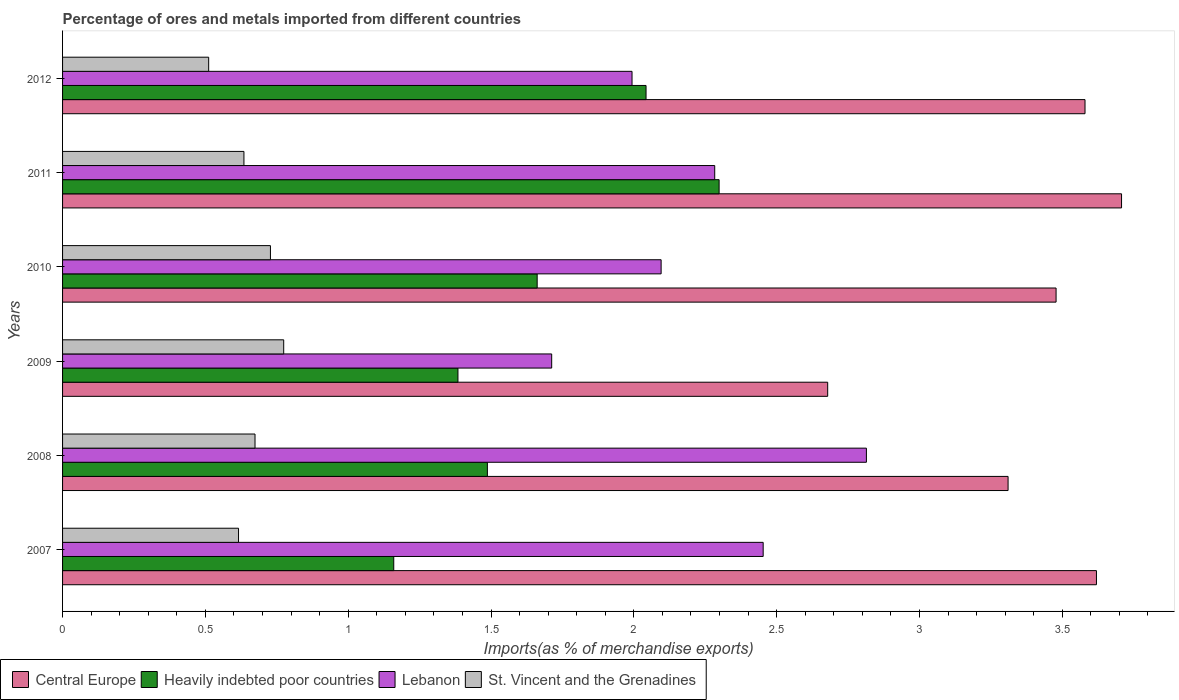How many different coloured bars are there?
Keep it short and to the point. 4. Are the number of bars on each tick of the Y-axis equal?
Give a very brief answer. Yes. What is the label of the 2nd group of bars from the top?
Your answer should be very brief. 2011. In how many cases, is the number of bars for a given year not equal to the number of legend labels?
Keep it short and to the point. 0. What is the percentage of imports to different countries in Lebanon in 2010?
Keep it short and to the point. 2.1. Across all years, what is the maximum percentage of imports to different countries in Heavily indebted poor countries?
Your response must be concise. 2.3. Across all years, what is the minimum percentage of imports to different countries in Heavily indebted poor countries?
Offer a terse response. 1.16. In which year was the percentage of imports to different countries in Central Europe minimum?
Your response must be concise. 2009. What is the total percentage of imports to different countries in Heavily indebted poor countries in the graph?
Your answer should be very brief. 10.03. What is the difference between the percentage of imports to different countries in St. Vincent and the Grenadines in 2009 and that in 2012?
Offer a very short reply. 0.26. What is the difference between the percentage of imports to different countries in Lebanon in 2010 and the percentage of imports to different countries in St. Vincent and the Grenadines in 2007?
Your response must be concise. 1.48. What is the average percentage of imports to different countries in St. Vincent and the Grenadines per year?
Give a very brief answer. 0.66. In the year 2009, what is the difference between the percentage of imports to different countries in St. Vincent and the Grenadines and percentage of imports to different countries in Heavily indebted poor countries?
Make the answer very short. -0.61. What is the ratio of the percentage of imports to different countries in Heavily indebted poor countries in 2011 to that in 2012?
Give a very brief answer. 1.13. Is the percentage of imports to different countries in Heavily indebted poor countries in 2011 less than that in 2012?
Provide a succinct answer. No. Is the difference between the percentage of imports to different countries in St. Vincent and the Grenadines in 2007 and 2010 greater than the difference between the percentage of imports to different countries in Heavily indebted poor countries in 2007 and 2010?
Offer a very short reply. Yes. What is the difference between the highest and the second highest percentage of imports to different countries in Central Europe?
Provide a succinct answer. 0.09. What is the difference between the highest and the lowest percentage of imports to different countries in Central Europe?
Your answer should be very brief. 1.03. What does the 4th bar from the top in 2011 represents?
Give a very brief answer. Central Europe. What does the 4th bar from the bottom in 2009 represents?
Make the answer very short. St. Vincent and the Grenadines. Is it the case that in every year, the sum of the percentage of imports to different countries in St. Vincent and the Grenadines and percentage of imports to different countries in Heavily indebted poor countries is greater than the percentage of imports to different countries in Lebanon?
Ensure brevity in your answer.  No. Are all the bars in the graph horizontal?
Offer a terse response. Yes. What is the difference between two consecutive major ticks on the X-axis?
Offer a terse response. 0.5. Does the graph contain any zero values?
Offer a terse response. No. How are the legend labels stacked?
Your answer should be compact. Horizontal. What is the title of the graph?
Provide a succinct answer. Percentage of ores and metals imported from different countries. Does "Thailand" appear as one of the legend labels in the graph?
Ensure brevity in your answer.  No. What is the label or title of the X-axis?
Ensure brevity in your answer.  Imports(as % of merchandise exports). What is the Imports(as % of merchandise exports) in Central Europe in 2007?
Offer a very short reply. 3.62. What is the Imports(as % of merchandise exports) of Heavily indebted poor countries in 2007?
Your answer should be compact. 1.16. What is the Imports(as % of merchandise exports) of Lebanon in 2007?
Your answer should be compact. 2.45. What is the Imports(as % of merchandise exports) in St. Vincent and the Grenadines in 2007?
Keep it short and to the point. 0.62. What is the Imports(as % of merchandise exports) in Central Europe in 2008?
Your answer should be compact. 3.31. What is the Imports(as % of merchandise exports) of Heavily indebted poor countries in 2008?
Provide a short and direct response. 1.49. What is the Imports(as % of merchandise exports) in Lebanon in 2008?
Ensure brevity in your answer.  2.81. What is the Imports(as % of merchandise exports) in St. Vincent and the Grenadines in 2008?
Ensure brevity in your answer.  0.67. What is the Imports(as % of merchandise exports) in Central Europe in 2009?
Your response must be concise. 2.68. What is the Imports(as % of merchandise exports) in Heavily indebted poor countries in 2009?
Ensure brevity in your answer.  1.38. What is the Imports(as % of merchandise exports) in Lebanon in 2009?
Provide a succinct answer. 1.71. What is the Imports(as % of merchandise exports) of St. Vincent and the Grenadines in 2009?
Your answer should be very brief. 0.77. What is the Imports(as % of merchandise exports) of Central Europe in 2010?
Provide a short and direct response. 3.48. What is the Imports(as % of merchandise exports) in Heavily indebted poor countries in 2010?
Your answer should be compact. 1.66. What is the Imports(as % of merchandise exports) of Lebanon in 2010?
Offer a very short reply. 2.1. What is the Imports(as % of merchandise exports) in St. Vincent and the Grenadines in 2010?
Your answer should be compact. 0.73. What is the Imports(as % of merchandise exports) of Central Europe in 2011?
Ensure brevity in your answer.  3.71. What is the Imports(as % of merchandise exports) in Heavily indebted poor countries in 2011?
Make the answer very short. 2.3. What is the Imports(as % of merchandise exports) in Lebanon in 2011?
Your response must be concise. 2.28. What is the Imports(as % of merchandise exports) in St. Vincent and the Grenadines in 2011?
Give a very brief answer. 0.64. What is the Imports(as % of merchandise exports) of Central Europe in 2012?
Keep it short and to the point. 3.58. What is the Imports(as % of merchandise exports) of Heavily indebted poor countries in 2012?
Offer a very short reply. 2.04. What is the Imports(as % of merchandise exports) in Lebanon in 2012?
Provide a short and direct response. 1.99. What is the Imports(as % of merchandise exports) of St. Vincent and the Grenadines in 2012?
Give a very brief answer. 0.51. Across all years, what is the maximum Imports(as % of merchandise exports) of Central Europe?
Keep it short and to the point. 3.71. Across all years, what is the maximum Imports(as % of merchandise exports) of Heavily indebted poor countries?
Provide a short and direct response. 2.3. Across all years, what is the maximum Imports(as % of merchandise exports) in Lebanon?
Offer a terse response. 2.81. Across all years, what is the maximum Imports(as % of merchandise exports) in St. Vincent and the Grenadines?
Keep it short and to the point. 0.77. Across all years, what is the minimum Imports(as % of merchandise exports) in Central Europe?
Give a very brief answer. 2.68. Across all years, what is the minimum Imports(as % of merchandise exports) of Heavily indebted poor countries?
Keep it short and to the point. 1.16. Across all years, what is the minimum Imports(as % of merchandise exports) of Lebanon?
Provide a succinct answer. 1.71. Across all years, what is the minimum Imports(as % of merchandise exports) of St. Vincent and the Grenadines?
Your answer should be very brief. 0.51. What is the total Imports(as % of merchandise exports) of Central Europe in the graph?
Your response must be concise. 20.37. What is the total Imports(as % of merchandise exports) in Heavily indebted poor countries in the graph?
Provide a short and direct response. 10.03. What is the total Imports(as % of merchandise exports) in Lebanon in the graph?
Provide a succinct answer. 13.35. What is the total Imports(as % of merchandise exports) of St. Vincent and the Grenadines in the graph?
Your answer should be compact. 3.94. What is the difference between the Imports(as % of merchandise exports) of Central Europe in 2007 and that in 2008?
Your answer should be compact. 0.31. What is the difference between the Imports(as % of merchandise exports) in Heavily indebted poor countries in 2007 and that in 2008?
Ensure brevity in your answer.  -0.33. What is the difference between the Imports(as % of merchandise exports) of Lebanon in 2007 and that in 2008?
Offer a terse response. -0.36. What is the difference between the Imports(as % of merchandise exports) of St. Vincent and the Grenadines in 2007 and that in 2008?
Ensure brevity in your answer.  -0.06. What is the difference between the Imports(as % of merchandise exports) of Central Europe in 2007 and that in 2009?
Make the answer very short. 0.94. What is the difference between the Imports(as % of merchandise exports) in Heavily indebted poor countries in 2007 and that in 2009?
Provide a succinct answer. -0.22. What is the difference between the Imports(as % of merchandise exports) in Lebanon in 2007 and that in 2009?
Provide a succinct answer. 0.74. What is the difference between the Imports(as % of merchandise exports) in St. Vincent and the Grenadines in 2007 and that in 2009?
Provide a short and direct response. -0.16. What is the difference between the Imports(as % of merchandise exports) of Central Europe in 2007 and that in 2010?
Give a very brief answer. 0.14. What is the difference between the Imports(as % of merchandise exports) in Heavily indebted poor countries in 2007 and that in 2010?
Provide a short and direct response. -0.5. What is the difference between the Imports(as % of merchandise exports) in Lebanon in 2007 and that in 2010?
Ensure brevity in your answer.  0.36. What is the difference between the Imports(as % of merchandise exports) of St. Vincent and the Grenadines in 2007 and that in 2010?
Provide a succinct answer. -0.11. What is the difference between the Imports(as % of merchandise exports) of Central Europe in 2007 and that in 2011?
Give a very brief answer. -0.09. What is the difference between the Imports(as % of merchandise exports) of Heavily indebted poor countries in 2007 and that in 2011?
Your answer should be very brief. -1.14. What is the difference between the Imports(as % of merchandise exports) in Lebanon in 2007 and that in 2011?
Offer a terse response. 0.17. What is the difference between the Imports(as % of merchandise exports) in St. Vincent and the Grenadines in 2007 and that in 2011?
Provide a short and direct response. -0.02. What is the difference between the Imports(as % of merchandise exports) of Heavily indebted poor countries in 2007 and that in 2012?
Provide a short and direct response. -0.88. What is the difference between the Imports(as % of merchandise exports) of Lebanon in 2007 and that in 2012?
Your response must be concise. 0.46. What is the difference between the Imports(as % of merchandise exports) in St. Vincent and the Grenadines in 2007 and that in 2012?
Give a very brief answer. 0.1. What is the difference between the Imports(as % of merchandise exports) of Central Europe in 2008 and that in 2009?
Your answer should be very brief. 0.63. What is the difference between the Imports(as % of merchandise exports) in Heavily indebted poor countries in 2008 and that in 2009?
Give a very brief answer. 0.1. What is the difference between the Imports(as % of merchandise exports) in Lebanon in 2008 and that in 2009?
Your answer should be compact. 1.1. What is the difference between the Imports(as % of merchandise exports) of St. Vincent and the Grenadines in 2008 and that in 2009?
Keep it short and to the point. -0.1. What is the difference between the Imports(as % of merchandise exports) in Central Europe in 2008 and that in 2010?
Offer a terse response. -0.17. What is the difference between the Imports(as % of merchandise exports) in Heavily indebted poor countries in 2008 and that in 2010?
Offer a terse response. -0.17. What is the difference between the Imports(as % of merchandise exports) of Lebanon in 2008 and that in 2010?
Give a very brief answer. 0.72. What is the difference between the Imports(as % of merchandise exports) in St. Vincent and the Grenadines in 2008 and that in 2010?
Your answer should be very brief. -0.05. What is the difference between the Imports(as % of merchandise exports) in Central Europe in 2008 and that in 2011?
Your answer should be compact. -0.4. What is the difference between the Imports(as % of merchandise exports) in Heavily indebted poor countries in 2008 and that in 2011?
Offer a terse response. -0.81. What is the difference between the Imports(as % of merchandise exports) of Lebanon in 2008 and that in 2011?
Offer a terse response. 0.53. What is the difference between the Imports(as % of merchandise exports) in St. Vincent and the Grenadines in 2008 and that in 2011?
Provide a short and direct response. 0.04. What is the difference between the Imports(as % of merchandise exports) of Central Europe in 2008 and that in 2012?
Give a very brief answer. -0.27. What is the difference between the Imports(as % of merchandise exports) in Heavily indebted poor countries in 2008 and that in 2012?
Give a very brief answer. -0.56. What is the difference between the Imports(as % of merchandise exports) in Lebanon in 2008 and that in 2012?
Provide a short and direct response. 0.82. What is the difference between the Imports(as % of merchandise exports) of St. Vincent and the Grenadines in 2008 and that in 2012?
Your answer should be compact. 0.16. What is the difference between the Imports(as % of merchandise exports) of Central Europe in 2009 and that in 2010?
Provide a succinct answer. -0.8. What is the difference between the Imports(as % of merchandise exports) in Heavily indebted poor countries in 2009 and that in 2010?
Your response must be concise. -0.28. What is the difference between the Imports(as % of merchandise exports) in Lebanon in 2009 and that in 2010?
Give a very brief answer. -0.38. What is the difference between the Imports(as % of merchandise exports) of St. Vincent and the Grenadines in 2009 and that in 2010?
Your answer should be very brief. 0.05. What is the difference between the Imports(as % of merchandise exports) of Central Europe in 2009 and that in 2011?
Keep it short and to the point. -1.03. What is the difference between the Imports(as % of merchandise exports) of Heavily indebted poor countries in 2009 and that in 2011?
Your answer should be very brief. -0.91. What is the difference between the Imports(as % of merchandise exports) in Lebanon in 2009 and that in 2011?
Offer a very short reply. -0.57. What is the difference between the Imports(as % of merchandise exports) of St. Vincent and the Grenadines in 2009 and that in 2011?
Make the answer very short. 0.14. What is the difference between the Imports(as % of merchandise exports) of Central Europe in 2009 and that in 2012?
Offer a terse response. -0.9. What is the difference between the Imports(as % of merchandise exports) in Heavily indebted poor countries in 2009 and that in 2012?
Make the answer very short. -0.66. What is the difference between the Imports(as % of merchandise exports) of Lebanon in 2009 and that in 2012?
Your response must be concise. -0.28. What is the difference between the Imports(as % of merchandise exports) of St. Vincent and the Grenadines in 2009 and that in 2012?
Keep it short and to the point. 0.26. What is the difference between the Imports(as % of merchandise exports) in Central Europe in 2010 and that in 2011?
Provide a short and direct response. -0.23. What is the difference between the Imports(as % of merchandise exports) of Heavily indebted poor countries in 2010 and that in 2011?
Your response must be concise. -0.64. What is the difference between the Imports(as % of merchandise exports) in Lebanon in 2010 and that in 2011?
Your answer should be very brief. -0.19. What is the difference between the Imports(as % of merchandise exports) in St. Vincent and the Grenadines in 2010 and that in 2011?
Your answer should be compact. 0.09. What is the difference between the Imports(as % of merchandise exports) of Central Europe in 2010 and that in 2012?
Provide a short and direct response. -0.1. What is the difference between the Imports(as % of merchandise exports) of Heavily indebted poor countries in 2010 and that in 2012?
Keep it short and to the point. -0.38. What is the difference between the Imports(as % of merchandise exports) of Lebanon in 2010 and that in 2012?
Offer a terse response. 0.1. What is the difference between the Imports(as % of merchandise exports) in St. Vincent and the Grenadines in 2010 and that in 2012?
Make the answer very short. 0.22. What is the difference between the Imports(as % of merchandise exports) of Central Europe in 2011 and that in 2012?
Offer a very short reply. 0.13. What is the difference between the Imports(as % of merchandise exports) in Heavily indebted poor countries in 2011 and that in 2012?
Provide a short and direct response. 0.26. What is the difference between the Imports(as % of merchandise exports) of Lebanon in 2011 and that in 2012?
Your response must be concise. 0.29. What is the difference between the Imports(as % of merchandise exports) of St. Vincent and the Grenadines in 2011 and that in 2012?
Your answer should be very brief. 0.12. What is the difference between the Imports(as % of merchandise exports) of Central Europe in 2007 and the Imports(as % of merchandise exports) of Heavily indebted poor countries in 2008?
Your response must be concise. 2.13. What is the difference between the Imports(as % of merchandise exports) in Central Europe in 2007 and the Imports(as % of merchandise exports) in Lebanon in 2008?
Offer a very short reply. 0.81. What is the difference between the Imports(as % of merchandise exports) of Central Europe in 2007 and the Imports(as % of merchandise exports) of St. Vincent and the Grenadines in 2008?
Your answer should be very brief. 2.95. What is the difference between the Imports(as % of merchandise exports) in Heavily indebted poor countries in 2007 and the Imports(as % of merchandise exports) in Lebanon in 2008?
Keep it short and to the point. -1.65. What is the difference between the Imports(as % of merchandise exports) in Heavily indebted poor countries in 2007 and the Imports(as % of merchandise exports) in St. Vincent and the Grenadines in 2008?
Your response must be concise. 0.49. What is the difference between the Imports(as % of merchandise exports) of Lebanon in 2007 and the Imports(as % of merchandise exports) of St. Vincent and the Grenadines in 2008?
Make the answer very short. 1.78. What is the difference between the Imports(as % of merchandise exports) of Central Europe in 2007 and the Imports(as % of merchandise exports) of Heavily indebted poor countries in 2009?
Your answer should be very brief. 2.24. What is the difference between the Imports(as % of merchandise exports) in Central Europe in 2007 and the Imports(as % of merchandise exports) in Lebanon in 2009?
Give a very brief answer. 1.91. What is the difference between the Imports(as % of merchandise exports) in Central Europe in 2007 and the Imports(as % of merchandise exports) in St. Vincent and the Grenadines in 2009?
Keep it short and to the point. 2.85. What is the difference between the Imports(as % of merchandise exports) in Heavily indebted poor countries in 2007 and the Imports(as % of merchandise exports) in Lebanon in 2009?
Offer a very short reply. -0.55. What is the difference between the Imports(as % of merchandise exports) of Heavily indebted poor countries in 2007 and the Imports(as % of merchandise exports) of St. Vincent and the Grenadines in 2009?
Your response must be concise. 0.39. What is the difference between the Imports(as % of merchandise exports) in Lebanon in 2007 and the Imports(as % of merchandise exports) in St. Vincent and the Grenadines in 2009?
Give a very brief answer. 1.68. What is the difference between the Imports(as % of merchandise exports) in Central Europe in 2007 and the Imports(as % of merchandise exports) in Heavily indebted poor countries in 2010?
Offer a very short reply. 1.96. What is the difference between the Imports(as % of merchandise exports) of Central Europe in 2007 and the Imports(as % of merchandise exports) of Lebanon in 2010?
Your answer should be very brief. 1.52. What is the difference between the Imports(as % of merchandise exports) in Central Europe in 2007 and the Imports(as % of merchandise exports) in St. Vincent and the Grenadines in 2010?
Your response must be concise. 2.89. What is the difference between the Imports(as % of merchandise exports) of Heavily indebted poor countries in 2007 and the Imports(as % of merchandise exports) of Lebanon in 2010?
Give a very brief answer. -0.94. What is the difference between the Imports(as % of merchandise exports) of Heavily indebted poor countries in 2007 and the Imports(as % of merchandise exports) of St. Vincent and the Grenadines in 2010?
Your response must be concise. 0.43. What is the difference between the Imports(as % of merchandise exports) in Lebanon in 2007 and the Imports(as % of merchandise exports) in St. Vincent and the Grenadines in 2010?
Ensure brevity in your answer.  1.73. What is the difference between the Imports(as % of merchandise exports) in Central Europe in 2007 and the Imports(as % of merchandise exports) in Heavily indebted poor countries in 2011?
Provide a short and direct response. 1.32. What is the difference between the Imports(as % of merchandise exports) of Central Europe in 2007 and the Imports(as % of merchandise exports) of Lebanon in 2011?
Keep it short and to the point. 1.34. What is the difference between the Imports(as % of merchandise exports) in Central Europe in 2007 and the Imports(as % of merchandise exports) in St. Vincent and the Grenadines in 2011?
Give a very brief answer. 2.98. What is the difference between the Imports(as % of merchandise exports) of Heavily indebted poor countries in 2007 and the Imports(as % of merchandise exports) of Lebanon in 2011?
Offer a very short reply. -1.12. What is the difference between the Imports(as % of merchandise exports) of Heavily indebted poor countries in 2007 and the Imports(as % of merchandise exports) of St. Vincent and the Grenadines in 2011?
Your answer should be compact. 0.52. What is the difference between the Imports(as % of merchandise exports) in Lebanon in 2007 and the Imports(as % of merchandise exports) in St. Vincent and the Grenadines in 2011?
Your response must be concise. 1.82. What is the difference between the Imports(as % of merchandise exports) in Central Europe in 2007 and the Imports(as % of merchandise exports) in Heavily indebted poor countries in 2012?
Make the answer very short. 1.58. What is the difference between the Imports(as % of merchandise exports) in Central Europe in 2007 and the Imports(as % of merchandise exports) in Lebanon in 2012?
Provide a succinct answer. 1.63. What is the difference between the Imports(as % of merchandise exports) of Central Europe in 2007 and the Imports(as % of merchandise exports) of St. Vincent and the Grenadines in 2012?
Make the answer very short. 3.11. What is the difference between the Imports(as % of merchandise exports) of Heavily indebted poor countries in 2007 and the Imports(as % of merchandise exports) of Lebanon in 2012?
Provide a succinct answer. -0.83. What is the difference between the Imports(as % of merchandise exports) of Heavily indebted poor countries in 2007 and the Imports(as % of merchandise exports) of St. Vincent and the Grenadines in 2012?
Offer a terse response. 0.65. What is the difference between the Imports(as % of merchandise exports) of Lebanon in 2007 and the Imports(as % of merchandise exports) of St. Vincent and the Grenadines in 2012?
Ensure brevity in your answer.  1.94. What is the difference between the Imports(as % of merchandise exports) in Central Europe in 2008 and the Imports(as % of merchandise exports) in Heavily indebted poor countries in 2009?
Keep it short and to the point. 1.93. What is the difference between the Imports(as % of merchandise exports) in Central Europe in 2008 and the Imports(as % of merchandise exports) in Lebanon in 2009?
Offer a terse response. 1.6. What is the difference between the Imports(as % of merchandise exports) of Central Europe in 2008 and the Imports(as % of merchandise exports) of St. Vincent and the Grenadines in 2009?
Offer a very short reply. 2.54. What is the difference between the Imports(as % of merchandise exports) of Heavily indebted poor countries in 2008 and the Imports(as % of merchandise exports) of Lebanon in 2009?
Offer a very short reply. -0.23. What is the difference between the Imports(as % of merchandise exports) of Heavily indebted poor countries in 2008 and the Imports(as % of merchandise exports) of St. Vincent and the Grenadines in 2009?
Offer a very short reply. 0.71. What is the difference between the Imports(as % of merchandise exports) of Lebanon in 2008 and the Imports(as % of merchandise exports) of St. Vincent and the Grenadines in 2009?
Your answer should be very brief. 2.04. What is the difference between the Imports(as % of merchandise exports) in Central Europe in 2008 and the Imports(as % of merchandise exports) in Heavily indebted poor countries in 2010?
Your answer should be compact. 1.65. What is the difference between the Imports(as % of merchandise exports) in Central Europe in 2008 and the Imports(as % of merchandise exports) in Lebanon in 2010?
Offer a very short reply. 1.21. What is the difference between the Imports(as % of merchandise exports) in Central Europe in 2008 and the Imports(as % of merchandise exports) in St. Vincent and the Grenadines in 2010?
Your response must be concise. 2.58. What is the difference between the Imports(as % of merchandise exports) of Heavily indebted poor countries in 2008 and the Imports(as % of merchandise exports) of Lebanon in 2010?
Provide a succinct answer. -0.61. What is the difference between the Imports(as % of merchandise exports) in Heavily indebted poor countries in 2008 and the Imports(as % of merchandise exports) in St. Vincent and the Grenadines in 2010?
Your answer should be compact. 0.76. What is the difference between the Imports(as % of merchandise exports) of Lebanon in 2008 and the Imports(as % of merchandise exports) of St. Vincent and the Grenadines in 2010?
Offer a terse response. 2.09. What is the difference between the Imports(as % of merchandise exports) in Central Europe in 2008 and the Imports(as % of merchandise exports) in Heavily indebted poor countries in 2011?
Provide a short and direct response. 1.01. What is the difference between the Imports(as % of merchandise exports) of Central Europe in 2008 and the Imports(as % of merchandise exports) of Lebanon in 2011?
Provide a short and direct response. 1.03. What is the difference between the Imports(as % of merchandise exports) in Central Europe in 2008 and the Imports(as % of merchandise exports) in St. Vincent and the Grenadines in 2011?
Ensure brevity in your answer.  2.68. What is the difference between the Imports(as % of merchandise exports) of Heavily indebted poor countries in 2008 and the Imports(as % of merchandise exports) of Lebanon in 2011?
Provide a short and direct response. -0.8. What is the difference between the Imports(as % of merchandise exports) of Heavily indebted poor countries in 2008 and the Imports(as % of merchandise exports) of St. Vincent and the Grenadines in 2011?
Provide a succinct answer. 0.85. What is the difference between the Imports(as % of merchandise exports) in Lebanon in 2008 and the Imports(as % of merchandise exports) in St. Vincent and the Grenadines in 2011?
Your answer should be compact. 2.18. What is the difference between the Imports(as % of merchandise exports) of Central Europe in 2008 and the Imports(as % of merchandise exports) of Heavily indebted poor countries in 2012?
Offer a terse response. 1.27. What is the difference between the Imports(as % of merchandise exports) of Central Europe in 2008 and the Imports(as % of merchandise exports) of Lebanon in 2012?
Make the answer very short. 1.32. What is the difference between the Imports(as % of merchandise exports) in Central Europe in 2008 and the Imports(as % of merchandise exports) in St. Vincent and the Grenadines in 2012?
Your response must be concise. 2.8. What is the difference between the Imports(as % of merchandise exports) in Heavily indebted poor countries in 2008 and the Imports(as % of merchandise exports) in Lebanon in 2012?
Give a very brief answer. -0.51. What is the difference between the Imports(as % of merchandise exports) of Heavily indebted poor countries in 2008 and the Imports(as % of merchandise exports) of St. Vincent and the Grenadines in 2012?
Offer a terse response. 0.98. What is the difference between the Imports(as % of merchandise exports) of Lebanon in 2008 and the Imports(as % of merchandise exports) of St. Vincent and the Grenadines in 2012?
Keep it short and to the point. 2.3. What is the difference between the Imports(as % of merchandise exports) of Central Europe in 2009 and the Imports(as % of merchandise exports) of Heavily indebted poor countries in 2010?
Offer a terse response. 1.02. What is the difference between the Imports(as % of merchandise exports) of Central Europe in 2009 and the Imports(as % of merchandise exports) of Lebanon in 2010?
Your answer should be compact. 0.58. What is the difference between the Imports(as % of merchandise exports) of Central Europe in 2009 and the Imports(as % of merchandise exports) of St. Vincent and the Grenadines in 2010?
Your answer should be compact. 1.95. What is the difference between the Imports(as % of merchandise exports) of Heavily indebted poor countries in 2009 and the Imports(as % of merchandise exports) of Lebanon in 2010?
Give a very brief answer. -0.71. What is the difference between the Imports(as % of merchandise exports) of Heavily indebted poor countries in 2009 and the Imports(as % of merchandise exports) of St. Vincent and the Grenadines in 2010?
Provide a short and direct response. 0.66. What is the difference between the Imports(as % of merchandise exports) of Lebanon in 2009 and the Imports(as % of merchandise exports) of St. Vincent and the Grenadines in 2010?
Give a very brief answer. 0.98. What is the difference between the Imports(as % of merchandise exports) of Central Europe in 2009 and the Imports(as % of merchandise exports) of Heavily indebted poor countries in 2011?
Provide a short and direct response. 0.38. What is the difference between the Imports(as % of merchandise exports) in Central Europe in 2009 and the Imports(as % of merchandise exports) in Lebanon in 2011?
Provide a short and direct response. 0.4. What is the difference between the Imports(as % of merchandise exports) in Central Europe in 2009 and the Imports(as % of merchandise exports) in St. Vincent and the Grenadines in 2011?
Your answer should be very brief. 2.04. What is the difference between the Imports(as % of merchandise exports) in Heavily indebted poor countries in 2009 and the Imports(as % of merchandise exports) in Lebanon in 2011?
Give a very brief answer. -0.9. What is the difference between the Imports(as % of merchandise exports) of Heavily indebted poor countries in 2009 and the Imports(as % of merchandise exports) of St. Vincent and the Grenadines in 2011?
Provide a short and direct response. 0.75. What is the difference between the Imports(as % of merchandise exports) of Lebanon in 2009 and the Imports(as % of merchandise exports) of St. Vincent and the Grenadines in 2011?
Offer a very short reply. 1.08. What is the difference between the Imports(as % of merchandise exports) in Central Europe in 2009 and the Imports(as % of merchandise exports) in Heavily indebted poor countries in 2012?
Your answer should be compact. 0.64. What is the difference between the Imports(as % of merchandise exports) in Central Europe in 2009 and the Imports(as % of merchandise exports) in Lebanon in 2012?
Your answer should be very brief. 0.69. What is the difference between the Imports(as % of merchandise exports) in Central Europe in 2009 and the Imports(as % of merchandise exports) in St. Vincent and the Grenadines in 2012?
Your response must be concise. 2.17. What is the difference between the Imports(as % of merchandise exports) of Heavily indebted poor countries in 2009 and the Imports(as % of merchandise exports) of Lebanon in 2012?
Provide a succinct answer. -0.61. What is the difference between the Imports(as % of merchandise exports) of Heavily indebted poor countries in 2009 and the Imports(as % of merchandise exports) of St. Vincent and the Grenadines in 2012?
Your response must be concise. 0.87. What is the difference between the Imports(as % of merchandise exports) of Lebanon in 2009 and the Imports(as % of merchandise exports) of St. Vincent and the Grenadines in 2012?
Keep it short and to the point. 1.2. What is the difference between the Imports(as % of merchandise exports) in Central Europe in 2010 and the Imports(as % of merchandise exports) in Heavily indebted poor countries in 2011?
Keep it short and to the point. 1.18. What is the difference between the Imports(as % of merchandise exports) of Central Europe in 2010 and the Imports(as % of merchandise exports) of Lebanon in 2011?
Keep it short and to the point. 1.2. What is the difference between the Imports(as % of merchandise exports) of Central Europe in 2010 and the Imports(as % of merchandise exports) of St. Vincent and the Grenadines in 2011?
Provide a short and direct response. 2.84. What is the difference between the Imports(as % of merchandise exports) in Heavily indebted poor countries in 2010 and the Imports(as % of merchandise exports) in Lebanon in 2011?
Offer a very short reply. -0.62. What is the difference between the Imports(as % of merchandise exports) in Heavily indebted poor countries in 2010 and the Imports(as % of merchandise exports) in St. Vincent and the Grenadines in 2011?
Your response must be concise. 1.03. What is the difference between the Imports(as % of merchandise exports) of Lebanon in 2010 and the Imports(as % of merchandise exports) of St. Vincent and the Grenadines in 2011?
Keep it short and to the point. 1.46. What is the difference between the Imports(as % of merchandise exports) in Central Europe in 2010 and the Imports(as % of merchandise exports) in Heavily indebted poor countries in 2012?
Keep it short and to the point. 1.44. What is the difference between the Imports(as % of merchandise exports) of Central Europe in 2010 and the Imports(as % of merchandise exports) of Lebanon in 2012?
Keep it short and to the point. 1.48. What is the difference between the Imports(as % of merchandise exports) of Central Europe in 2010 and the Imports(as % of merchandise exports) of St. Vincent and the Grenadines in 2012?
Give a very brief answer. 2.97. What is the difference between the Imports(as % of merchandise exports) in Heavily indebted poor countries in 2010 and the Imports(as % of merchandise exports) in Lebanon in 2012?
Provide a short and direct response. -0.33. What is the difference between the Imports(as % of merchandise exports) in Heavily indebted poor countries in 2010 and the Imports(as % of merchandise exports) in St. Vincent and the Grenadines in 2012?
Offer a very short reply. 1.15. What is the difference between the Imports(as % of merchandise exports) of Lebanon in 2010 and the Imports(as % of merchandise exports) of St. Vincent and the Grenadines in 2012?
Your answer should be compact. 1.58. What is the difference between the Imports(as % of merchandise exports) of Central Europe in 2011 and the Imports(as % of merchandise exports) of Heavily indebted poor countries in 2012?
Your answer should be compact. 1.66. What is the difference between the Imports(as % of merchandise exports) in Central Europe in 2011 and the Imports(as % of merchandise exports) in Lebanon in 2012?
Give a very brief answer. 1.71. What is the difference between the Imports(as % of merchandise exports) of Central Europe in 2011 and the Imports(as % of merchandise exports) of St. Vincent and the Grenadines in 2012?
Make the answer very short. 3.2. What is the difference between the Imports(as % of merchandise exports) of Heavily indebted poor countries in 2011 and the Imports(as % of merchandise exports) of Lebanon in 2012?
Offer a terse response. 0.3. What is the difference between the Imports(as % of merchandise exports) in Heavily indebted poor countries in 2011 and the Imports(as % of merchandise exports) in St. Vincent and the Grenadines in 2012?
Make the answer very short. 1.79. What is the difference between the Imports(as % of merchandise exports) in Lebanon in 2011 and the Imports(as % of merchandise exports) in St. Vincent and the Grenadines in 2012?
Your response must be concise. 1.77. What is the average Imports(as % of merchandise exports) in Central Europe per year?
Your response must be concise. 3.4. What is the average Imports(as % of merchandise exports) of Heavily indebted poor countries per year?
Your answer should be very brief. 1.67. What is the average Imports(as % of merchandise exports) in Lebanon per year?
Your answer should be compact. 2.23. What is the average Imports(as % of merchandise exports) of St. Vincent and the Grenadines per year?
Ensure brevity in your answer.  0.66. In the year 2007, what is the difference between the Imports(as % of merchandise exports) in Central Europe and Imports(as % of merchandise exports) in Heavily indebted poor countries?
Offer a terse response. 2.46. In the year 2007, what is the difference between the Imports(as % of merchandise exports) of Central Europe and Imports(as % of merchandise exports) of Lebanon?
Your response must be concise. 1.17. In the year 2007, what is the difference between the Imports(as % of merchandise exports) in Central Europe and Imports(as % of merchandise exports) in St. Vincent and the Grenadines?
Ensure brevity in your answer.  3. In the year 2007, what is the difference between the Imports(as % of merchandise exports) of Heavily indebted poor countries and Imports(as % of merchandise exports) of Lebanon?
Keep it short and to the point. -1.29. In the year 2007, what is the difference between the Imports(as % of merchandise exports) in Heavily indebted poor countries and Imports(as % of merchandise exports) in St. Vincent and the Grenadines?
Give a very brief answer. 0.54. In the year 2007, what is the difference between the Imports(as % of merchandise exports) in Lebanon and Imports(as % of merchandise exports) in St. Vincent and the Grenadines?
Make the answer very short. 1.84. In the year 2008, what is the difference between the Imports(as % of merchandise exports) of Central Europe and Imports(as % of merchandise exports) of Heavily indebted poor countries?
Provide a succinct answer. 1.82. In the year 2008, what is the difference between the Imports(as % of merchandise exports) in Central Europe and Imports(as % of merchandise exports) in Lebanon?
Provide a short and direct response. 0.5. In the year 2008, what is the difference between the Imports(as % of merchandise exports) of Central Europe and Imports(as % of merchandise exports) of St. Vincent and the Grenadines?
Provide a short and direct response. 2.64. In the year 2008, what is the difference between the Imports(as % of merchandise exports) in Heavily indebted poor countries and Imports(as % of merchandise exports) in Lebanon?
Offer a terse response. -1.33. In the year 2008, what is the difference between the Imports(as % of merchandise exports) in Heavily indebted poor countries and Imports(as % of merchandise exports) in St. Vincent and the Grenadines?
Your response must be concise. 0.81. In the year 2008, what is the difference between the Imports(as % of merchandise exports) in Lebanon and Imports(as % of merchandise exports) in St. Vincent and the Grenadines?
Your answer should be compact. 2.14. In the year 2009, what is the difference between the Imports(as % of merchandise exports) in Central Europe and Imports(as % of merchandise exports) in Heavily indebted poor countries?
Make the answer very short. 1.29. In the year 2009, what is the difference between the Imports(as % of merchandise exports) in Central Europe and Imports(as % of merchandise exports) in Lebanon?
Make the answer very short. 0.97. In the year 2009, what is the difference between the Imports(as % of merchandise exports) in Central Europe and Imports(as % of merchandise exports) in St. Vincent and the Grenadines?
Provide a short and direct response. 1.9. In the year 2009, what is the difference between the Imports(as % of merchandise exports) of Heavily indebted poor countries and Imports(as % of merchandise exports) of Lebanon?
Give a very brief answer. -0.33. In the year 2009, what is the difference between the Imports(as % of merchandise exports) of Heavily indebted poor countries and Imports(as % of merchandise exports) of St. Vincent and the Grenadines?
Your response must be concise. 0.61. In the year 2009, what is the difference between the Imports(as % of merchandise exports) in Lebanon and Imports(as % of merchandise exports) in St. Vincent and the Grenadines?
Offer a terse response. 0.94. In the year 2010, what is the difference between the Imports(as % of merchandise exports) of Central Europe and Imports(as % of merchandise exports) of Heavily indebted poor countries?
Your answer should be compact. 1.82. In the year 2010, what is the difference between the Imports(as % of merchandise exports) in Central Europe and Imports(as % of merchandise exports) in Lebanon?
Your answer should be very brief. 1.38. In the year 2010, what is the difference between the Imports(as % of merchandise exports) in Central Europe and Imports(as % of merchandise exports) in St. Vincent and the Grenadines?
Ensure brevity in your answer.  2.75. In the year 2010, what is the difference between the Imports(as % of merchandise exports) in Heavily indebted poor countries and Imports(as % of merchandise exports) in Lebanon?
Offer a terse response. -0.43. In the year 2010, what is the difference between the Imports(as % of merchandise exports) in Heavily indebted poor countries and Imports(as % of merchandise exports) in St. Vincent and the Grenadines?
Ensure brevity in your answer.  0.93. In the year 2010, what is the difference between the Imports(as % of merchandise exports) of Lebanon and Imports(as % of merchandise exports) of St. Vincent and the Grenadines?
Keep it short and to the point. 1.37. In the year 2011, what is the difference between the Imports(as % of merchandise exports) of Central Europe and Imports(as % of merchandise exports) of Heavily indebted poor countries?
Keep it short and to the point. 1.41. In the year 2011, what is the difference between the Imports(as % of merchandise exports) in Central Europe and Imports(as % of merchandise exports) in Lebanon?
Ensure brevity in your answer.  1.42. In the year 2011, what is the difference between the Imports(as % of merchandise exports) in Central Europe and Imports(as % of merchandise exports) in St. Vincent and the Grenadines?
Give a very brief answer. 3.07. In the year 2011, what is the difference between the Imports(as % of merchandise exports) in Heavily indebted poor countries and Imports(as % of merchandise exports) in Lebanon?
Give a very brief answer. 0.02. In the year 2011, what is the difference between the Imports(as % of merchandise exports) of Heavily indebted poor countries and Imports(as % of merchandise exports) of St. Vincent and the Grenadines?
Keep it short and to the point. 1.66. In the year 2011, what is the difference between the Imports(as % of merchandise exports) in Lebanon and Imports(as % of merchandise exports) in St. Vincent and the Grenadines?
Provide a short and direct response. 1.65. In the year 2012, what is the difference between the Imports(as % of merchandise exports) of Central Europe and Imports(as % of merchandise exports) of Heavily indebted poor countries?
Your answer should be very brief. 1.54. In the year 2012, what is the difference between the Imports(as % of merchandise exports) in Central Europe and Imports(as % of merchandise exports) in Lebanon?
Your answer should be very brief. 1.59. In the year 2012, what is the difference between the Imports(as % of merchandise exports) of Central Europe and Imports(as % of merchandise exports) of St. Vincent and the Grenadines?
Offer a very short reply. 3.07. In the year 2012, what is the difference between the Imports(as % of merchandise exports) of Heavily indebted poor countries and Imports(as % of merchandise exports) of Lebanon?
Your response must be concise. 0.05. In the year 2012, what is the difference between the Imports(as % of merchandise exports) in Heavily indebted poor countries and Imports(as % of merchandise exports) in St. Vincent and the Grenadines?
Your answer should be compact. 1.53. In the year 2012, what is the difference between the Imports(as % of merchandise exports) of Lebanon and Imports(as % of merchandise exports) of St. Vincent and the Grenadines?
Make the answer very short. 1.48. What is the ratio of the Imports(as % of merchandise exports) of Central Europe in 2007 to that in 2008?
Give a very brief answer. 1.09. What is the ratio of the Imports(as % of merchandise exports) in Heavily indebted poor countries in 2007 to that in 2008?
Offer a very short reply. 0.78. What is the ratio of the Imports(as % of merchandise exports) of Lebanon in 2007 to that in 2008?
Keep it short and to the point. 0.87. What is the ratio of the Imports(as % of merchandise exports) of St. Vincent and the Grenadines in 2007 to that in 2008?
Offer a very short reply. 0.91. What is the ratio of the Imports(as % of merchandise exports) in Central Europe in 2007 to that in 2009?
Offer a terse response. 1.35. What is the ratio of the Imports(as % of merchandise exports) in Heavily indebted poor countries in 2007 to that in 2009?
Your answer should be compact. 0.84. What is the ratio of the Imports(as % of merchandise exports) in Lebanon in 2007 to that in 2009?
Give a very brief answer. 1.43. What is the ratio of the Imports(as % of merchandise exports) of St. Vincent and the Grenadines in 2007 to that in 2009?
Keep it short and to the point. 0.8. What is the ratio of the Imports(as % of merchandise exports) in Central Europe in 2007 to that in 2010?
Your response must be concise. 1.04. What is the ratio of the Imports(as % of merchandise exports) in Heavily indebted poor countries in 2007 to that in 2010?
Your answer should be compact. 0.7. What is the ratio of the Imports(as % of merchandise exports) in Lebanon in 2007 to that in 2010?
Make the answer very short. 1.17. What is the ratio of the Imports(as % of merchandise exports) in St. Vincent and the Grenadines in 2007 to that in 2010?
Provide a short and direct response. 0.85. What is the ratio of the Imports(as % of merchandise exports) in Central Europe in 2007 to that in 2011?
Keep it short and to the point. 0.98. What is the ratio of the Imports(as % of merchandise exports) in Heavily indebted poor countries in 2007 to that in 2011?
Keep it short and to the point. 0.5. What is the ratio of the Imports(as % of merchandise exports) in Lebanon in 2007 to that in 2011?
Offer a very short reply. 1.07. What is the ratio of the Imports(as % of merchandise exports) of St. Vincent and the Grenadines in 2007 to that in 2011?
Provide a short and direct response. 0.97. What is the ratio of the Imports(as % of merchandise exports) of Central Europe in 2007 to that in 2012?
Your answer should be very brief. 1.01. What is the ratio of the Imports(as % of merchandise exports) of Heavily indebted poor countries in 2007 to that in 2012?
Your answer should be very brief. 0.57. What is the ratio of the Imports(as % of merchandise exports) in Lebanon in 2007 to that in 2012?
Offer a very short reply. 1.23. What is the ratio of the Imports(as % of merchandise exports) in St. Vincent and the Grenadines in 2007 to that in 2012?
Your answer should be compact. 1.2. What is the ratio of the Imports(as % of merchandise exports) in Central Europe in 2008 to that in 2009?
Give a very brief answer. 1.24. What is the ratio of the Imports(as % of merchandise exports) in Heavily indebted poor countries in 2008 to that in 2009?
Give a very brief answer. 1.07. What is the ratio of the Imports(as % of merchandise exports) of Lebanon in 2008 to that in 2009?
Your response must be concise. 1.64. What is the ratio of the Imports(as % of merchandise exports) in St. Vincent and the Grenadines in 2008 to that in 2009?
Ensure brevity in your answer.  0.87. What is the ratio of the Imports(as % of merchandise exports) in Central Europe in 2008 to that in 2010?
Provide a short and direct response. 0.95. What is the ratio of the Imports(as % of merchandise exports) of Heavily indebted poor countries in 2008 to that in 2010?
Offer a terse response. 0.9. What is the ratio of the Imports(as % of merchandise exports) in Lebanon in 2008 to that in 2010?
Offer a terse response. 1.34. What is the ratio of the Imports(as % of merchandise exports) in St. Vincent and the Grenadines in 2008 to that in 2010?
Offer a very short reply. 0.93. What is the ratio of the Imports(as % of merchandise exports) in Central Europe in 2008 to that in 2011?
Keep it short and to the point. 0.89. What is the ratio of the Imports(as % of merchandise exports) in Heavily indebted poor countries in 2008 to that in 2011?
Provide a short and direct response. 0.65. What is the ratio of the Imports(as % of merchandise exports) of Lebanon in 2008 to that in 2011?
Make the answer very short. 1.23. What is the ratio of the Imports(as % of merchandise exports) in St. Vincent and the Grenadines in 2008 to that in 2011?
Your response must be concise. 1.06. What is the ratio of the Imports(as % of merchandise exports) of Central Europe in 2008 to that in 2012?
Your answer should be very brief. 0.92. What is the ratio of the Imports(as % of merchandise exports) in Heavily indebted poor countries in 2008 to that in 2012?
Give a very brief answer. 0.73. What is the ratio of the Imports(as % of merchandise exports) in Lebanon in 2008 to that in 2012?
Make the answer very short. 1.41. What is the ratio of the Imports(as % of merchandise exports) of St. Vincent and the Grenadines in 2008 to that in 2012?
Keep it short and to the point. 1.32. What is the ratio of the Imports(as % of merchandise exports) of Central Europe in 2009 to that in 2010?
Offer a very short reply. 0.77. What is the ratio of the Imports(as % of merchandise exports) of Heavily indebted poor countries in 2009 to that in 2010?
Provide a short and direct response. 0.83. What is the ratio of the Imports(as % of merchandise exports) in Lebanon in 2009 to that in 2010?
Provide a succinct answer. 0.82. What is the ratio of the Imports(as % of merchandise exports) of St. Vincent and the Grenadines in 2009 to that in 2010?
Offer a terse response. 1.06. What is the ratio of the Imports(as % of merchandise exports) of Central Europe in 2009 to that in 2011?
Make the answer very short. 0.72. What is the ratio of the Imports(as % of merchandise exports) of Heavily indebted poor countries in 2009 to that in 2011?
Make the answer very short. 0.6. What is the ratio of the Imports(as % of merchandise exports) in Lebanon in 2009 to that in 2011?
Your answer should be compact. 0.75. What is the ratio of the Imports(as % of merchandise exports) of St. Vincent and the Grenadines in 2009 to that in 2011?
Give a very brief answer. 1.22. What is the ratio of the Imports(as % of merchandise exports) in Central Europe in 2009 to that in 2012?
Your answer should be compact. 0.75. What is the ratio of the Imports(as % of merchandise exports) in Heavily indebted poor countries in 2009 to that in 2012?
Ensure brevity in your answer.  0.68. What is the ratio of the Imports(as % of merchandise exports) in Lebanon in 2009 to that in 2012?
Keep it short and to the point. 0.86. What is the ratio of the Imports(as % of merchandise exports) of St. Vincent and the Grenadines in 2009 to that in 2012?
Make the answer very short. 1.51. What is the ratio of the Imports(as % of merchandise exports) in Central Europe in 2010 to that in 2011?
Provide a short and direct response. 0.94. What is the ratio of the Imports(as % of merchandise exports) in Heavily indebted poor countries in 2010 to that in 2011?
Make the answer very short. 0.72. What is the ratio of the Imports(as % of merchandise exports) in Lebanon in 2010 to that in 2011?
Provide a succinct answer. 0.92. What is the ratio of the Imports(as % of merchandise exports) in St. Vincent and the Grenadines in 2010 to that in 2011?
Ensure brevity in your answer.  1.15. What is the ratio of the Imports(as % of merchandise exports) in Central Europe in 2010 to that in 2012?
Your answer should be very brief. 0.97. What is the ratio of the Imports(as % of merchandise exports) of Heavily indebted poor countries in 2010 to that in 2012?
Provide a succinct answer. 0.81. What is the ratio of the Imports(as % of merchandise exports) in Lebanon in 2010 to that in 2012?
Offer a terse response. 1.05. What is the ratio of the Imports(as % of merchandise exports) of St. Vincent and the Grenadines in 2010 to that in 2012?
Give a very brief answer. 1.42. What is the ratio of the Imports(as % of merchandise exports) in Central Europe in 2011 to that in 2012?
Ensure brevity in your answer.  1.04. What is the ratio of the Imports(as % of merchandise exports) of Heavily indebted poor countries in 2011 to that in 2012?
Give a very brief answer. 1.13. What is the ratio of the Imports(as % of merchandise exports) of Lebanon in 2011 to that in 2012?
Offer a terse response. 1.15. What is the ratio of the Imports(as % of merchandise exports) in St. Vincent and the Grenadines in 2011 to that in 2012?
Your answer should be compact. 1.24. What is the difference between the highest and the second highest Imports(as % of merchandise exports) in Central Europe?
Keep it short and to the point. 0.09. What is the difference between the highest and the second highest Imports(as % of merchandise exports) of Heavily indebted poor countries?
Offer a terse response. 0.26. What is the difference between the highest and the second highest Imports(as % of merchandise exports) of Lebanon?
Your response must be concise. 0.36. What is the difference between the highest and the second highest Imports(as % of merchandise exports) in St. Vincent and the Grenadines?
Your answer should be very brief. 0.05. What is the difference between the highest and the lowest Imports(as % of merchandise exports) of Central Europe?
Make the answer very short. 1.03. What is the difference between the highest and the lowest Imports(as % of merchandise exports) in Heavily indebted poor countries?
Offer a terse response. 1.14. What is the difference between the highest and the lowest Imports(as % of merchandise exports) of Lebanon?
Your response must be concise. 1.1. What is the difference between the highest and the lowest Imports(as % of merchandise exports) of St. Vincent and the Grenadines?
Ensure brevity in your answer.  0.26. 